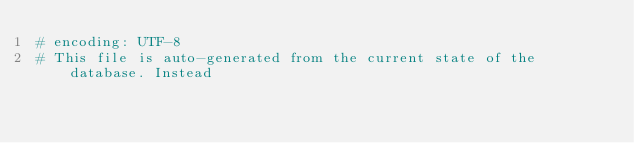Convert code to text. <code><loc_0><loc_0><loc_500><loc_500><_Ruby_># encoding: UTF-8
# This file is auto-generated from the current state of the database. Instead</code> 